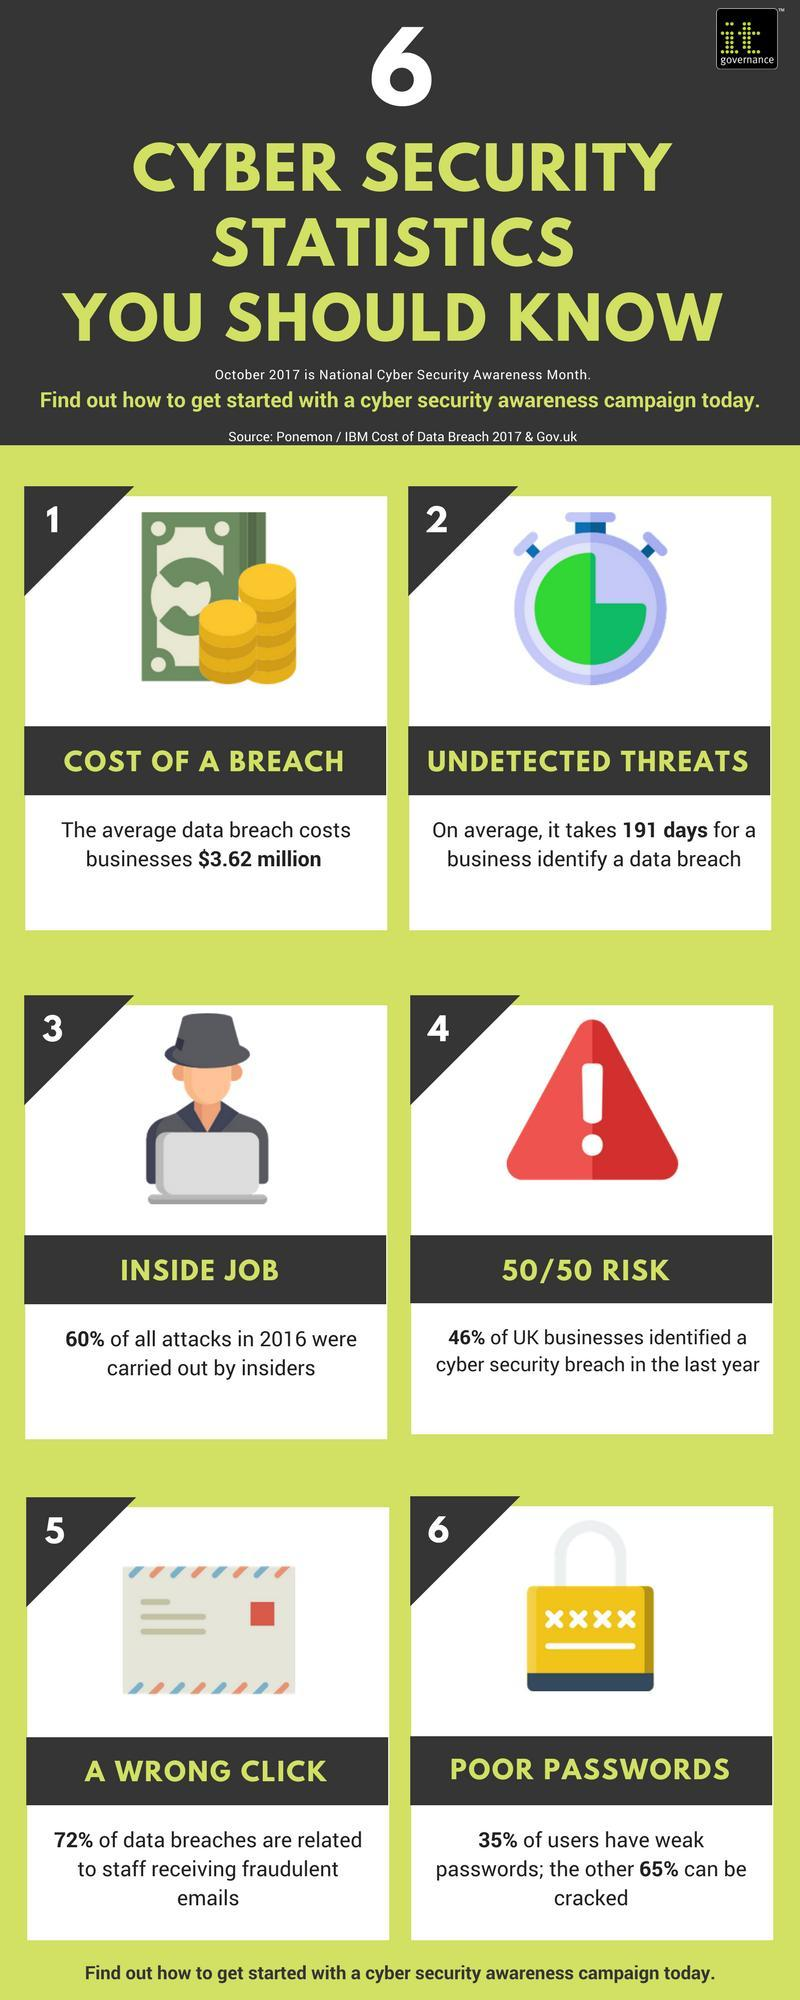How many images are shown in each column ?
Answer the question with a short phrase. 3 What percent of breaches were caused from fraudulent emails ? 72% What picture does image 5 show , envelope triangle or clock ? Envelope How many images are shown in each row ? 2 What percent of users have passwords that can be easily decoded ? 65% What percent of Cyber attacks are from within the organisation itself ? 60% How long does it take on an average for businesses to identify undetected threats ? 191 days What percent of UK businesses did not have a cyber security breach in the last year ? 54% What percent of Cyber attacks in 2016 were by outsiders ? 40% In the fourth image what is the colour of the exclamation mark within the triangle, red, black or white ? White 